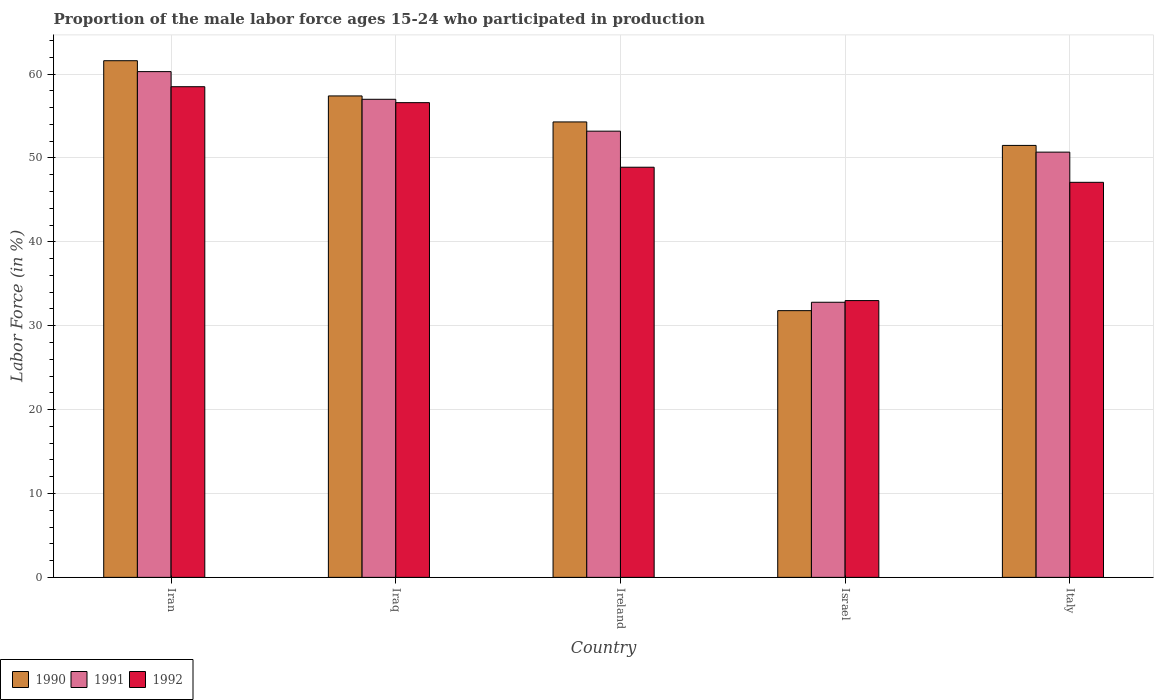How many groups of bars are there?
Make the answer very short. 5. Are the number of bars per tick equal to the number of legend labels?
Give a very brief answer. Yes. Are the number of bars on each tick of the X-axis equal?
Provide a short and direct response. Yes. How many bars are there on the 5th tick from the left?
Give a very brief answer. 3. What is the label of the 4th group of bars from the left?
Make the answer very short. Israel. In how many cases, is the number of bars for a given country not equal to the number of legend labels?
Make the answer very short. 0. What is the proportion of the male labor force who participated in production in 1992 in Israel?
Your answer should be compact. 33. Across all countries, what is the maximum proportion of the male labor force who participated in production in 1992?
Keep it short and to the point. 58.5. Across all countries, what is the minimum proportion of the male labor force who participated in production in 1992?
Offer a terse response. 33. In which country was the proportion of the male labor force who participated in production in 1991 maximum?
Ensure brevity in your answer.  Iran. What is the total proportion of the male labor force who participated in production in 1991 in the graph?
Your answer should be compact. 254. What is the difference between the proportion of the male labor force who participated in production in 1991 in Ireland and that in Italy?
Offer a very short reply. 2.5. What is the difference between the proportion of the male labor force who participated in production in 1991 in Ireland and the proportion of the male labor force who participated in production in 1992 in Israel?
Ensure brevity in your answer.  20.2. What is the average proportion of the male labor force who participated in production in 1992 per country?
Provide a succinct answer. 48.82. What is the difference between the proportion of the male labor force who participated in production of/in 1992 and proportion of the male labor force who participated in production of/in 1991 in Iraq?
Your response must be concise. -0.4. What is the ratio of the proportion of the male labor force who participated in production in 1992 in Iran to that in Ireland?
Make the answer very short. 1.2. What is the difference between the highest and the second highest proportion of the male labor force who participated in production in 1992?
Your answer should be compact. -1.9. In how many countries, is the proportion of the male labor force who participated in production in 1992 greater than the average proportion of the male labor force who participated in production in 1992 taken over all countries?
Your response must be concise. 3. Is the sum of the proportion of the male labor force who participated in production in 1991 in Ireland and Israel greater than the maximum proportion of the male labor force who participated in production in 1992 across all countries?
Provide a short and direct response. Yes. What does the 2nd bar from the right in Iran represents?
Give a very brief answer. 1991. How many bars are there?
Your response must be concise. 15. Are all the bars in the graph horizontal?
Offer a terse response. No. Are the values on the major ticks of Y-axis written in scientific E-notation?
Provide a succinct answer. No. Where does the legend appear in the graph?
Offer a very short reply. Bottom left. How many legend labels are there?
Make the answer very short. 3. What is the title of the graph?
Your answer should be very brief. Proportion of the male labor force ages 15-24 who participated in production. What is the label or title of the X-axis?
Your answer should be very brief. Country. What is the label or title of the Y-axis?
Provide a succinct answer. Labor Force (in %). What is the Labor Force (in %) of 1990 in Iran?
Ensure brevity in your answer.  61.6. What is the Labor Force (in %) in 1991 in Iran?
Your answer should be compact. 60.3. What is the Labor Force (in %) in 1992 in Iran?
Offer a terse response. 58.5. What is the Labor Force (in %) in 1990 in Iraq?
Make the answer very short. 57.4. What is the Labor Force (in %) in 1992 in Iraq?
Your answer should be very brief. 56.6. What is the Labor Force (in %) in 1990 in Ireland?
Offer a terse response. 54.3. What is the Labor Force (in %) of 1991 in Ireland?
Offer a terse response. 53.2. What is the Labor Force (in %) in 1992 in Ireland?
Keep it short and to the point. 48.9. What is the Labor Force (in %) of 1990 in Israel?
Provide a succinct answer. 31.8. What is the Labor Force (in %) in 1991 in Israel?
Give a very brief answer. 32.8. What is the Labor Force (in %) of 1992 in Israel?
Ensure brevity in your answer.  33. What is the Labor Force (in %) in 1990 in Italy?
Give a very brief answer. 51.5. What is the Labor Force (in %) of 1991 in Italy?
Provide a succinct answer. 50.7. What is the Labor Force (in %) of 1992 in Italy?
Give a very brief answer. 47.1. Across all countries, what is the maximum Labor Force (in %) of 1990?
Provide a succinct answer. 61.6. Across all countries, what is the maximum Labor Force (in %) in 1991?
Offer a very short reply. 60.3. Across all countries, what is the maximum Labor Force (in %) in 1992?
Keep it short and to the point. 58.5. Across all countries, what is the minimum Labor Force (in %) in 1990?
Provide a short and direct response. 31.8. Across all countries, what is the minimum Labor Force (in %) in 1991?
Offer a terse response. 32.8. Across all countries, what is the minimum Labor Force (in %) of 1992?
Your response must be concise. 33. What is the total Labor Force (in %) of 1990 in the graph?
Keep it short and to the point. 256.6. What is the total Labor Force (in %) of 1991 in the graph?
Provide a succinct answer. 254. What is the total Labor Force (in %) of 1992 in the graph?
Make the answer very short. 244.1. What is the difference between the Labor Force (in %) in 1992 in Iran and that in Iraq?
Provide a succinct answer. 1.9. What is the difference between the Labor Force (in %) in 1991 in Iran and that in Ireland?
Ensure brevity in your answer.  7.1. What is the difference between the Labor Force (in %) in 1990 in Iran and that in Israel?
Offer a very short reply. 29.8. What is the difference between the Labor Force (in %) of 1990 in Iran and that in Italy?
Make the answer very short. 10.1. What is the difference between the Labor Force (in %) of 1992 in Iran and that in Italy?
Make the answer very short. 11.4. What is the difference between the Labor Force (in %) of 1991 in Iraq and that in Ireland?
Your answer should be very brief. 3.8. What is the difference between the Labor Force (in %) of 1992 in Iraq and that in Ireland?
Provide a short and direct response. 7.7. What is the difference between the Labor Force (in %) in 1990 in Iraq and that in Israel?
Your answer should be very brief. 25.6. What is the difference between the Labor Force (in %) of 1991 in Iraq and that in Israel?
Ensure brevity in your answer.  24.2. What is the difference between the Labor Force (in %) in 1992 in Iraq and that in Israel?
Keep it short and to the point. 23.6. What is the difference between the Labor Force (in %) in 1992 in Iraq and that in Italy?
Your answer should be compact. 9.5. What is the difference between the Labor Force (in %) in 1990 in Ireland and that in Israel?
Your response must be concise. 22.5. What is the difference between the Labor Force (in %) of 1991 in Ireland and that in Israel?
Offer a very short reply. 20.4. What is the difference between the Labor Force (in %) of 1992 in Ireland and that in Israel?
Keep it short and to the point. 15.9. What is the difference between the Labor Force (in %) in 1991 in Ireland and that in Italy?
Your answer should be compact. 2.5. What is the difference between the Labor Force (in %) in 1992 in Ireland and that in Italy?
Give a very brief answer. 1.8. What is the difference between the Labor Force (in %) of 1990 in Israel and that in Italy?
Your answer should be very brief. -19.7. What is the difference between the Labor Force (in %) in 1991 in Israel and that in Italy?
Your response must be concise. -17.9. What is the difference between the Labor Force (in %) of 1992 in Israel and that in Italy?
Provide a succinct answer. -14.1. What is the difference between the Labor Force (in %) in 1990 in Iran and the Labor Force (in %) in 1992 in Iraq?
Your response must be concise. 5. What is the difference between the Labor Force (in %) in 1990 in Iran and the Labor Force (in %) in 1991 in Ireland?
Offer a terse response. 8.4. What is the difference between the Labor Force (in %) in 1991 in Iran and the Labor Force (in %) in 1992 in Ireland?
Your answer should be very brief. 11.4. What is the difference between the Labor Force (in %) in 1990 in Iran and the Labor Force (in %) in 1991 in Israel?
Ensure brevity in your answer.  28.8. What is the difference between the Labor Force (in %) in 1990 in Iran and the Labor Force (in %) in 1992 in Israel?
Your response must be concise. 28.6. What is the difference between the Labor Force (in %) of 1991 in Iran and the Labor Force (in %) of 1992 in Israel?
Offer a very short reply. 27.3. What is the difference between the Labor Force (in %) of 1990 in Iran and the Labor Force (in %) of 1991 in Italy?
Offer a very short reply. 10.9. What is the difference between the Labor Force (in %) of 1990 in Iran and the Labor Force (in %) of 1992 in Italy?
Your answer should be compact. 14.5. What is the difference between the Labor Force (in %) in 1990 in Iraq and the Labor Force (in %) in 1991 in Ireland?
Your answer should be compact. 4.2. What is the difference between the Labor Force (in %) of 1990 in Iraq and the Labor Force (in %) of 1992 in Ireland?
Ensure brevity in your answer.  8.5. What is the difference between the Labor Force (in %) of 1990 in Iraq and the Labor Force (in %) of 1991 in Israel?
Provide a short and direct response. 24.6. What is the difference between the Labor Force (in %) in 1990 in Iraq and the Labor Force (in %) in 1992 in Israel?
Make the answer very short. 24.4. What is the difference between the Labor Force (in %) in 1991 in Iraq and the Labor Force (in %) in 1992 in Israel?
Provide a succinct answer. 24. What is the difference between the Labor Force (in %) of 1990 in Iraq and the Labor Force (in %) of 1991 in Italy?
Keep it short and to the point. 6.7. What is the difference between the Labor Force (in %) in 1990 in Iraq and the Labor Force (in %) in 1992 in Italy?
Your answer should be compact. 10.3. What is the difference between the Labor Force (in %) of 1990 in Ireland and the Labor Force (in %) of 1991 in Israel?
Your answer should be very brief. 21.5. What is the difference between the Labor Force (in %) in 1990 in Ireland and the Labor Force (in %) in 1992 in Israel?
Ensure brevity in your answer.  21.3. What is the difference between the Labor Force (in %) in 1991 in Ireland and the Labor Force (in %) in 1992 in Israel?
Provide a short and direct response. 20.2. What is the difference between the Labor Force (in %) of 1991 in Ireland and the Labor Force (in %) of 1992 in Italy?
Offer a terse response. 6.1. What is the difference between the Labor Force (in %) in 1990 in Israel and the Labor Force (in %) in 1991 in Italy?
Provide a short and direct response. -18.9. What is the difference between the Labor Force (in %) in 1990 in Israel and the Labor Force (in %) in 1992 in Italy?
Your answer should be very brief. -15.3. What is the difference between the Labor Force (in %) of 1991 in Israel and the Labor Force (in %) of 1992 in Italy?
Keep it short and to the point. -14.3. What is the average Labor Force (in %) of 1990 per country?
Your answer should be compact. 51.32. What is the average Labor Force (in %) of 1991 per country?
Keep it short and to the point. 50.8. What is the average Labor Force (in %) in 1992 per country?
Your answer should be compact. 48.82. What is the difference between the Labor Force (in %) in 1990 and Labor Force (in %) in 1992 in Iran?
Offer a very short reply. 3.1. What is the difference between the Labor Force (in %) in 1991 and Labor Force (in %) in 1992 in Iran?
Your answer should be very brief. 1.8. What is the difference between the Labor Force (in %) in 1990 and Labor Force (in %) in 1991 in Iraq?
Your answer should be very brief. 0.4. What is the difference between the Labor Force (in %) in 1990 and Labor Force (in %) in 1991 in Italy?
Keep it short and to the point. 0.8. What is the difference between the Labor Force (in %) of 1991 and Labor Force (in %) of 1992 in Italy?
Your answer should be compact. 3.6. What is the ratio of the Labor Force (in %) of 1990 in Iran to that in Iraq?
Make the answer very short. 1.07. What is the ratio of the Labor Force (in %) in 1991 in Iran to that in Iraq?
Ensure brevity in your answer.  1.06. What is the ratio of the Labor Force (in %) of 1992 in Iran to that in Iraq?
Offer a terse response. 1.03. What is the ratio of the Labor Force (in %) in 1990 in Iran to that in Ireland?
Keep it short and to the point. 1.13. What is the ratio of the Labor Force (in %) in 1991 in Iran to that in Ireland?
Offer a very short reply. 1.13. What is the ratio of the Labor Force (in %) of 1992 in Iran to that in Ireland?
Offer a terse response. 1.2. What is the ratio of the Labor Force (in %) in 1990 in Iran to that in Israel?
Your response must be concise. 1.94. What is the ratio of the Labor Force (in %) in 1991 in Iran to that in Israel?
Your answer should be compact. 1.84. What is the ratio of the Labor Force (in %) of 1992 in Iran to that in Israel?
Make the answer very short. 1.77. What is the ratio of the Labor Force (in %) in 1990 in Iran to that in Italy?
Give a very brief answer. 1.2. What is the ratio of the Labor Force (in %) in 1991 in Iran to that in Italy?
Your answer should be very brief. 1.19. What is the ratio of the Labor Force (in %) in 1992 in Iran to that in Italy?
Offer a terse response. 1.24. What is the ratio of the Labor Force (in %) of 1990 in Iraq to that in Ireland?
Make the answer very short. 1.06. What is the ratio of the Labor Force (in %) of 1991 in Iraq to that in Ireland?
Your response must be concise. 1.07. What is the ratio of the Labor Force (in %) in 1992 in Iraq to that in Ireland?
Give a very brief answer. 1.16. What is the ratio of the Labor Force (in %) of 1990 in Iraq to that in Israel?
Your answer should be compact. 1.8. What is the ratio of the Labor Force (in %) in 1991 in Iraq to that in Israel?
Your answer should be compact. 1.74. What is the ratio of the Labor Force (in %) of 1992 in Iraq to that in Israel?
Give a very brief answer. 1.72. What is the ratio of the Labor Force (in %) in 1990 in Iraq to that in Italy?
Provide a succinct answer. 1.11. What is the ratio of the Labor Force (in %) in 1991 in Iraq to that in Italy?
Provide a short and direct response. 1.12. What is the ratio of the Labor Force (in %) of 1992 in Iraq to that in Italy?
Your answer should be compact. 1.2. What is the ratio of the Labor Force (in %) of 1990 in Ireland to that in Israel?
Your answer should be very brief. 1.71. What is the ratio of the Labor Force (in %) of 1991 in Ireland to that in Israel?
Provide a short and direct response. 1.62. What is the ratio of the Labor Force (in %) in 1992 in Ireland to that in Israel?
Your answer should be compact. 1.48. What is the ratio of the Labor Force (in %) of 1990 in Ireland to that in Italy?
Your response must be concise. 1.05. What is the ratio of the Labor Force (in %) in 1991 in Ireland to that in Italy?
Your answer should be compact. 1.05. What is the ratio of the Labor Force (in %) of 1992 in Ireland to that in Italy?
Your answer should be very brief. 1.04. What is the ratio of the Labor Force (in %) of 1990 in Israel to that in Italy?
Your response must be concise. 0.62. What is the ratio of the Labor Force (in %) in 1991 in Israel to that in Italy?
Provide a short and direct response. 0.65. What is the ratio of the Labor Force (in %) in 1992 in Israel to that in Italy?
Keep it short and to the point. 0.7. What is the difference between the highest and the second highest Labor Force (in %) of 1990?
Make the answer very short. 4.2. What is the difference between the highest and the second highest Labor Force (in %) of 1992?
Your answer should be very brief. 1.9. What is the difference between the highest and the lowest Labor Force (in %) in 1990?
Your answer should be very brief. 29.8. 